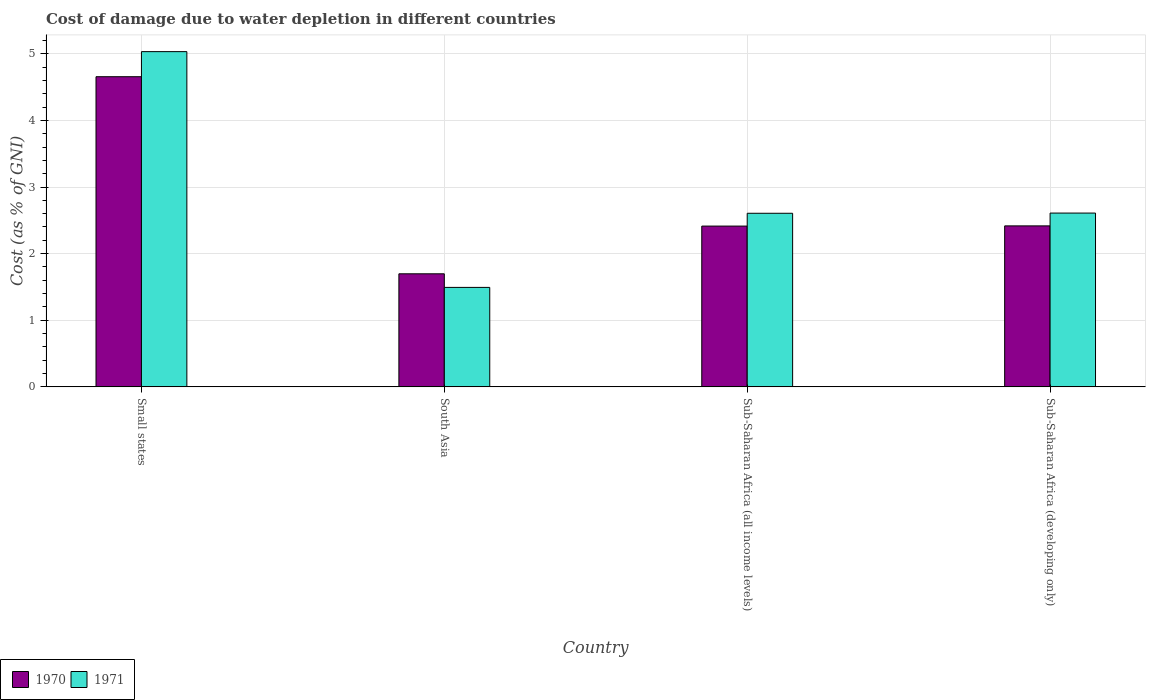Are the number of bars per tick equal to the number of legend labels?
Offer a terse response. Yes. How many bars are there on the 4th tick from the right?
Your response must be concise. 2. What is the label of the 2nd group of bars from the left?
Give a very brief answer. South Asia. In how many cases, is the number of bars for a given country not equal to the number of legend labels?
Give a very brief answer. 0. What is the cost of damage caused due to water depletion in 1971 in Sub-Saharan Africa (all income levels)?
Keep it short and to the point. 2.61. Across all countries, what is the maximum cost of damage caused due to water depletion in 1970?
Your answer should be very brief. 4.66. Across all countries, what is the minimum cost of damage caused due to water depletion in 1971?
Provide a short and direct response. 1.49. In which country was the cost of damage caused due to water depletion in 1971 maximum?
Your answer should be compact. Small states. What is the total cost of damage caused due to water depletion in 1971 in the graph?
Ensure brevity in your answer.  11.74. What is the difference between the cost of damage caused due to water depletion in 1971 in Small states and that in South Asia?
Provide a succinct answer. 3.54. What is the difference between the cost of damage caused due to water depletion in 1970 in Sub-Saharan Africa (all income levels) and the cost of damage caused due to water depletion in 1971 in Sub-Saharan Africa (developing only)?
Keep it short and to the point. -0.2. What is the average cost of damage caused due to water depletion in 1971 per country?
Offer a very short reply. 2.93. What is the difference between the cost of damage caused due to water depletion of/in 1970 and cost of damage caused due to water depletion of/in 1971 in Small states?
Your answer should be very brief. -0.38. What is the ratio of the cost of damage caused due to water depletion in 1971 in South Asia to that in Sub-Saharan Africa (developing only)?
Your answer should be compact. 0.57. Is the cost of damage caused due to water depletion in 1971 in Small states less than that in Sub-Saharan Africa (developing only)?
Your response must be concise. No. Is the difference between the cost of damage caused due to water depletion in 1970 in Small states and Sub-Saharan Africa (all income levels) greater than the difference between the cost of damage caused due to water depletion in 1971 in Small states and Sub-Saharan Africa (all income levels)?
Give a very brief answer. No. What is the difference between the highest and the second highest cost of damage caused due to water depletion in 1970?
Ensure brevity in your answer.  0. What is the difference between the highest and the lowest cost of damage caused due to water depletion in 1971?
Provide a succinct answer. 3.54. In how many countries, is the cost of damage caused due to water depletion in 1970 greater than the average cost of damage caused due to water depletion in 1970 taken over all countries?
Your answer should be compact. 1. What does the 2nd bar from the left in Sub-Saharan Africa (all income levels) represents?
Offer a terse response. 1971. How many countries are there in the graph?
Provide a short and direct response. 4. How are the legend labels stacked?
Offer a very short reply. Horizontal. What is the title of the graph?
Provide a short and direct response. Cost of damage due to water depletion in different countries. What is the label or title of the Y-axis?
Offer a very short reply. Cost (as % of GNI). What is the Cost (as % of GNI) of 1970 in Small states?
Offer a terse response. 4.66. What is the Cost (as % of GNI) in 1971 in Small states?
Offer a very short reply. 5.03. What is the Cost (as % of GNI) in 1970 in South Asia?
Offer a terse response. 1.7. What is the Cost (as % of GNI) in 1971 in South Asia?
Make the answer very short. 1.49. What is the Cost (as % of GNI) in 1970 in Sub-Saharan Africa (all income levels)?
Offer a terse response. 2.41. What is the Cost (as % of GNI) in 1971 in Sub-Saharan Africa (all income levels)?
Provide a succinct answer. 2.61. What is the Cost (as % of GNI) of 1970 in Sub-Saharan Africa (developing only)?
Provide a succinct answer. 2.42. What is the Cost (as % of GNI) in 1971 in Sub-Saharan Africa (developing only)?
Provide a short and direct response. 2.61. Across all countries, what is the maximum Cost (as % of GNI) in 1970?
Offer a terse response. 4.66. Across all countries, what is the maximum Cost (as % of GNI) in 1971?
Ensure brevity in your answer.  5.03. Across all countries, what is the minimum Cost (as % of GNI) in 1970?
Your answer should be compact. 1.7. Across all countries, what is the minimum Cost (as % of GNI) of 1971?
Provide a succinct answer. 1.49. What is the total Cost (as % of GNI) in 1970 in the graph?
Your response must be concise. 11.18. What is the total Cost (as % of GNI) of 1971 in the graph?
Offer a terse response. 11.74. What is the difference between the Cost (as % of GNI) of 1970 in Small states and that in South Asia?
Ensure brevity in your answer.  2.96. What is the difference between the Cost (as % of GNI) in 1971 in Small states and that in South Asia?
Your answer should be very brief. 3.54. What is the difference between the Cost (as % of GNI) in 1970 in Small states and that in Sub-Saharan Africa (all income levels)?
Make the answer very short. 2.24. What is the difference between the Cost (as % of GNI) of 1971 in Small states and that in Sub-Saharan Africa (all income levels)?
Your answer should be very brief. 2.43. What is the difference between the Cost (as % of GNI) in 1970 in Small states and that in Sub-Saharan Africa (developing only)?
Provide a short and direct response. 2.24. What is the difference between the Cost (as % of GNI) of 1971 in Small states and that in Sub-Saharan Africa (developing only)?
Give a very brief answer. 2.42. What is the difference between the Cost (as % of GNI) in 1970 in South Asia and that in Sub-Saharan Africa (all income levels)?
Offer a very short reply. -0.72. What is the difference between the Cost (as % of GNI) in 1971 in South Asia and that in Sub-Saharan Africa (all income levels)?
Give a very brief answer. -1.11. What is the difference between the Cost (as % of GNI) of 1970 in South Asia and that in Sub-Saharan Africa (developing only)?
Keep it short and to the point. -0.72. What is the difference between the Cost (as % of GNI) in 1971 in South Asia and that in Sub-Saharan Africa (developing only)?
Ensure brevity in your answer.  -1.12. What is the difference between the Cost (as % of GNI) in 1970 in Sub-Saharan Africa (all income levels) and that in Sub-Saharan Africa (developing only)?
Provide a short and direct response. -0. What is the difference between the Cost (as % of GNI) of 1971 in Sub-Saharan Africa (all income levels) and that in Sub-Saharan Africa (developing only)?
Ensure brevity in your answer.  -0. What is the difference between the Cost (as % of GNI) in 1970 in Small states and the Cost (as % of GNI) in 1971 in South Asia?
Keep it short and to the point. 3.16. What is the difference between the Cost (as % of GNI) of 1970 in Small states and the Cost (as % of GNI) of 1971 in Sub-Saharan Africa (all income levels)?
Ensure brevity in your answer.  2.05. What is the difference between the Cost (as % of GNI) in 1970 in Small states and the Cost (as % of GNI) in 1971 in Sub-Saharan Africa (developing only)?
Provide a short and direct response. 2.05. What is the difference between the Cost (as % of GNI) in 1970 in South Asia and the Cost (as % of GNI) in 1971 in Sub-Saharan Africa (all income levels)?
Your answer should be compact. -0.91. What is the difference between the Cost (as % of GNI) of 1970 in South Asia and the Cost (as % of GNI) of 1971 in Sub-Saharan Africa (developing only)?
Ensure brevity in your answer.  -0.91. What is the difference between the Cost (as % of GNI) in 1970 in Sub-Saharan Africa (all income levels) and the Cost (as % of GNI) in 1971 in Sub-Saharan Africa (developing only)?
Ensure brevity in your answer.  -0.2. What is the average Cost (as % of GNI) of 1970 per country?
Your answer should be very brief. 2.8. What is the average Cost (as % of GNI) in 1971 per country?
Give a very brief answer. 2.93. What is the difference between the Cost (as % of GNI) of 1970 and Cost (as % of GNI) of 1971 in Small states?
Give a very brief answer. -0.38. What is the difference between the Cost (as % of GNI) in 1970 and Cost (as % of GNI) in 1971 in South Asia?
Offer a very short reply. 0.2. What is the difference between the Cost (as % of GNI) in 1970 and Cost (as % of GNI) in 1971 in Sub-Saharan Africa (all income levels)?
Offer a very short reply. -0.19. What is the difference between the Cost (as % of GNI) in 1970 and Cost (as % of GNI) in 1971 in Sub-Saharan Africa (developing only)?
Offer a terse response. -0.19. What is the ratio of the Cost (as % of GNI) of 1970 in Small states to that in South Asia?
Give a very brief answer. 2.74. What is the ratio of the Cost (as % of GNI) in 1971 in Small states to that in South Asia?
Provide a succinct answer. 3.37. What is the ratio of the Cost (as % of GNI) in 1970 in Small states to that in Sub-Saharan Africa (all income levels)?
Keep it short and to the point. 1.93. What is the ratio of the Cost (as % of GNI) in 1971 in Small states to that in Sub-Saharan Africa (all income levels)?
Provide a short and direct response. 1.93. What is the ratio of the Cost (as % of GNI) in 1970 in Small states to that in Sub-Saharan Africa (developing only)?
Keep it short and to the point. 1.93. What is the ratio of the Cost (as % of GNI) in 1971 in Small states to that in Sub-Saharan Africa (developing only)?
Your answer should be compact. 1.93. What is the ratio of the Cost (as % of GNI) of 1970 in South Asia to that in Sub-Saharan Africa (all income levels)?
Your answer should be compact. 0.7. What is the ratio of the Cost (as % of GNI) in 1971 in South Asia to that in Sub-Saharan Africa (all income levels)?
Your response must be concise. 0.57. What is the ratio of the Cost (as % of GNI) of 1970 in South Asia to that in Sub-Saharan Africa (developing only)?
Make the answer very short. 0.7. What is the ratio of the Cost (as % of GNI) of 1971 in South Asia to that in Sub-Saharan Africa (developing only)?
Ensure brevity in your answer.  0.57. What is the ratio of the Cost (as % of GNI) of 1971 in Sub-Saharan Africa (all income levels) to that in Sub-Saharan Africa (developing only)?
Your answer should be very brief. 1. What is the difference between the highest and the second highest Cost (as % of GNI) in 1970?
Offer a terse response. 2.24. What is the difference between the highest and the second highest Cost (as % of GNI) in 1971?
Give a very brief answer. 2.42. What is the difference between the highest and the lowest Cost (as % of GNI) in 1970?
Keep it short and to the point. 2.96. What is the difference between the highest and the lowest Cost (as % of GNI) of 1971?
Offer a terse response. 3.54. 